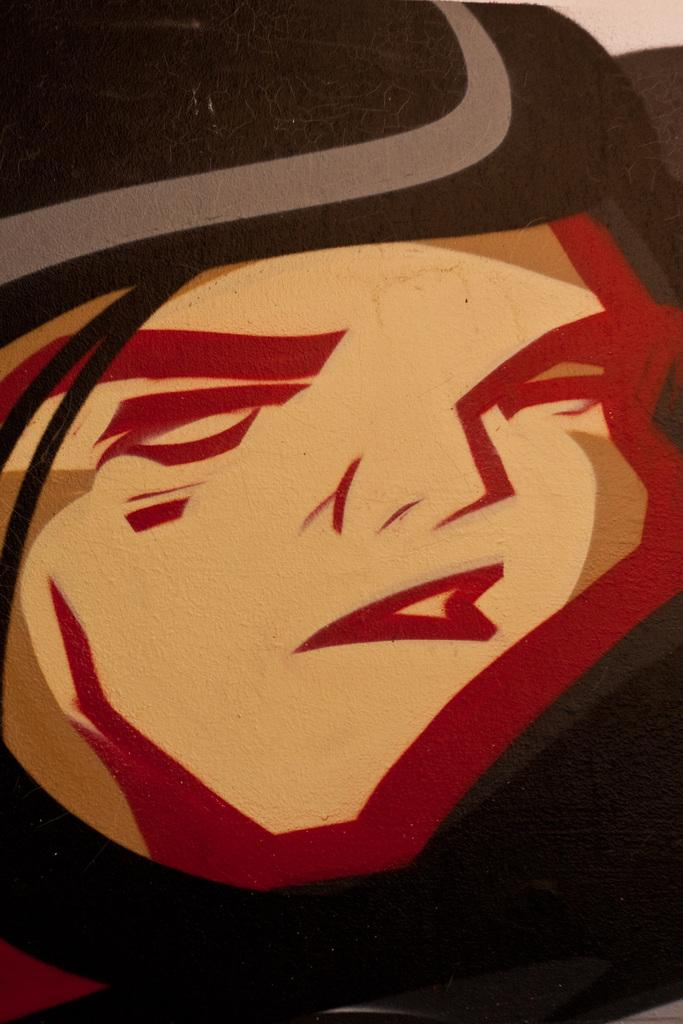What is the main subject of the image? There is a painting in the image. What is depicted in the painting? The painting depicts a person. Can you describe the person's attire in the painting? The person in the painting is wearing a hat. How many centimeters is the goose in the painting? There is no goose present in the painting; it depicts a person wearing a hat. What is the distance between the person and the edge of the painting? The provided facts do not give information about the distance between the person and the edge of the painting. 